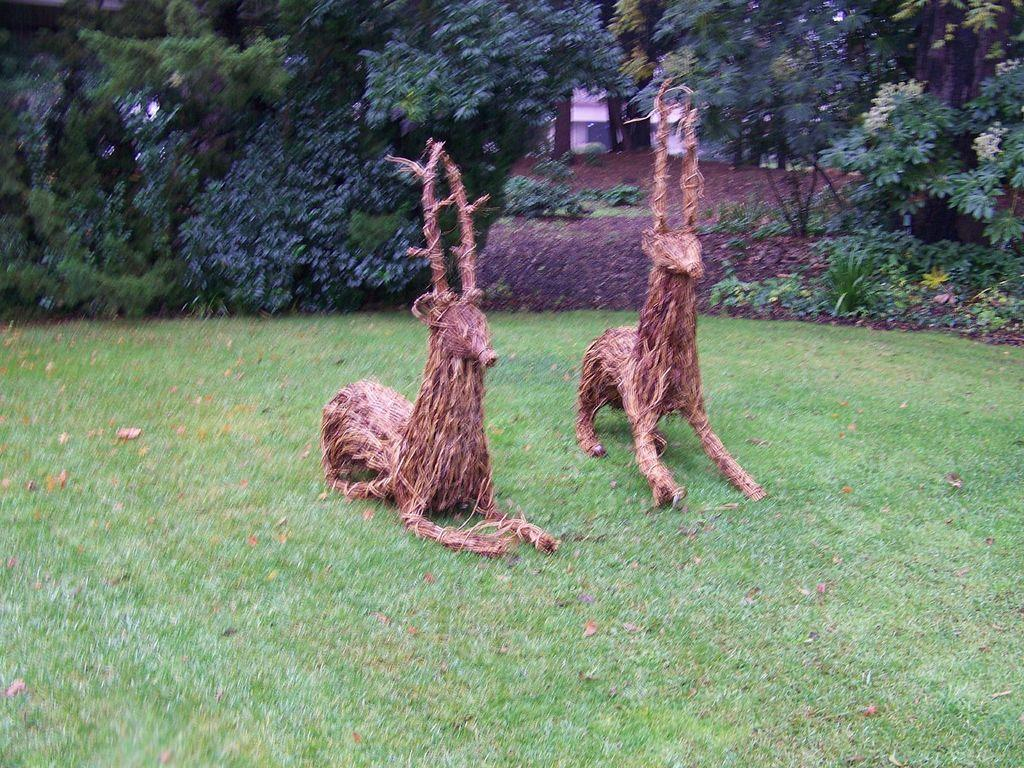What type of artwork can be seen in the image? There are sculptures in the image. What is covering the ground in the image? Dried leaves are present on the grass. Can you describe the grass be seen in the image? Yes, there is grass visible in the image. What can be seen in the background of the image? There are trees, plants, and a building in the background of the image. What is the value of the expert's opinion on the sculptures in the image? There is no expert present in the image, and therefore no expert opinion can be given. 